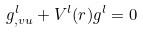<formula> <loc_0><loc_0><loc_500><loc_500>g _ { , v u } ^ { l } + V ^ { l } ( r ) g ^ { l } = 0</formula> 